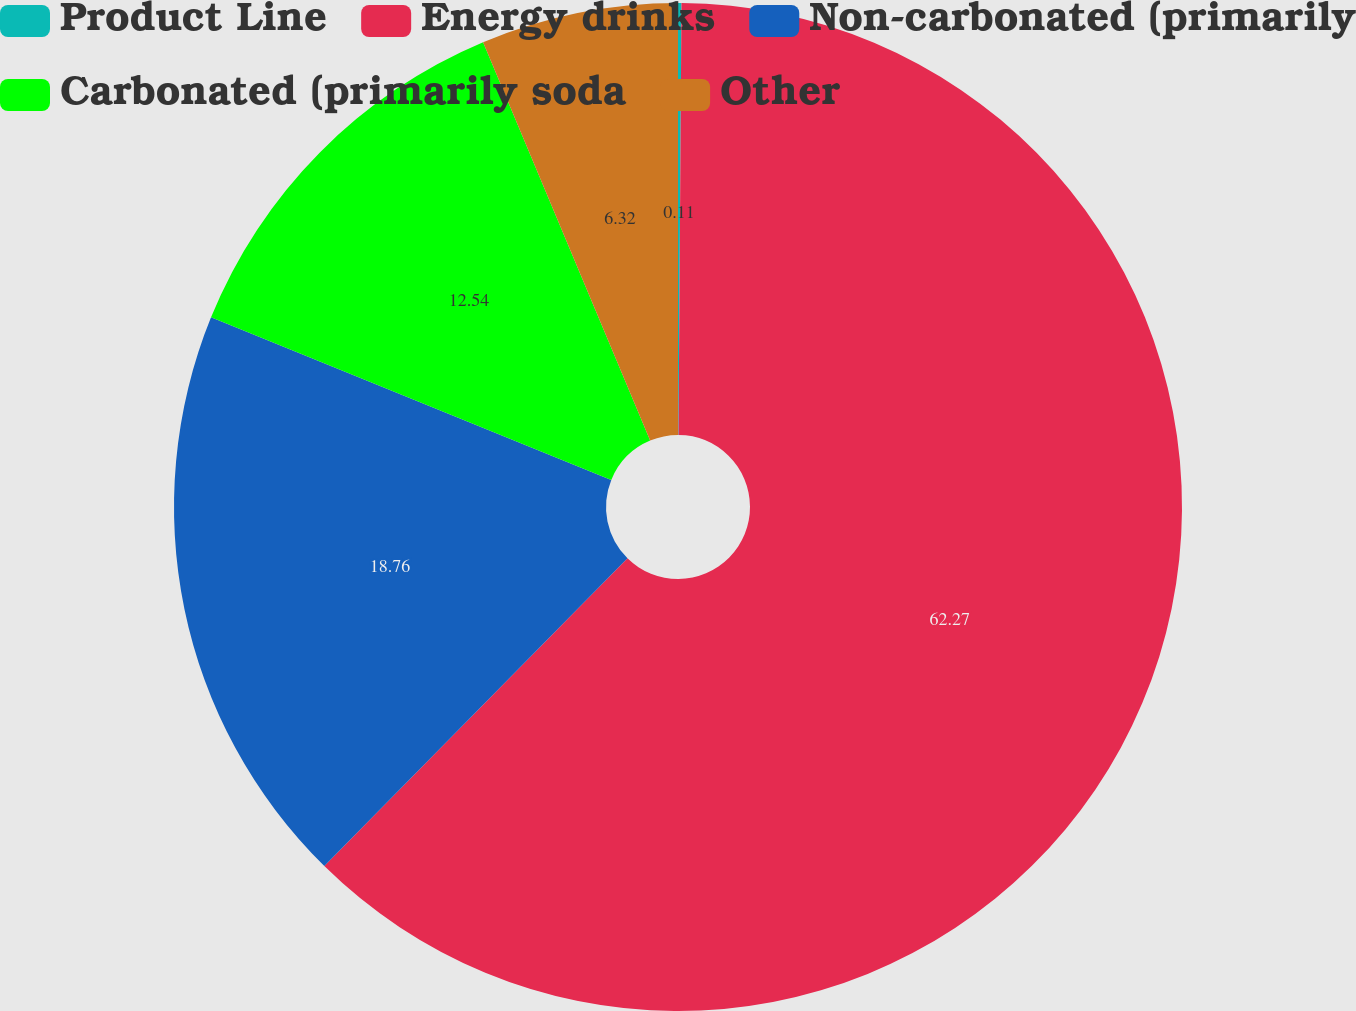<chart> <loc_0><loc_0><loc_500><loc_500><pie_chart><fcel>Product Line<fcel>Energy drinks<fcel>Non-carbonated (primarily<fcel>Carbonated (primarily soda<fcel>Other<nl><fcel>0.11%<fcel>62.27%<fcel>18.76%<fcel>12.54%<fcel>6.32%<nl></chart> 